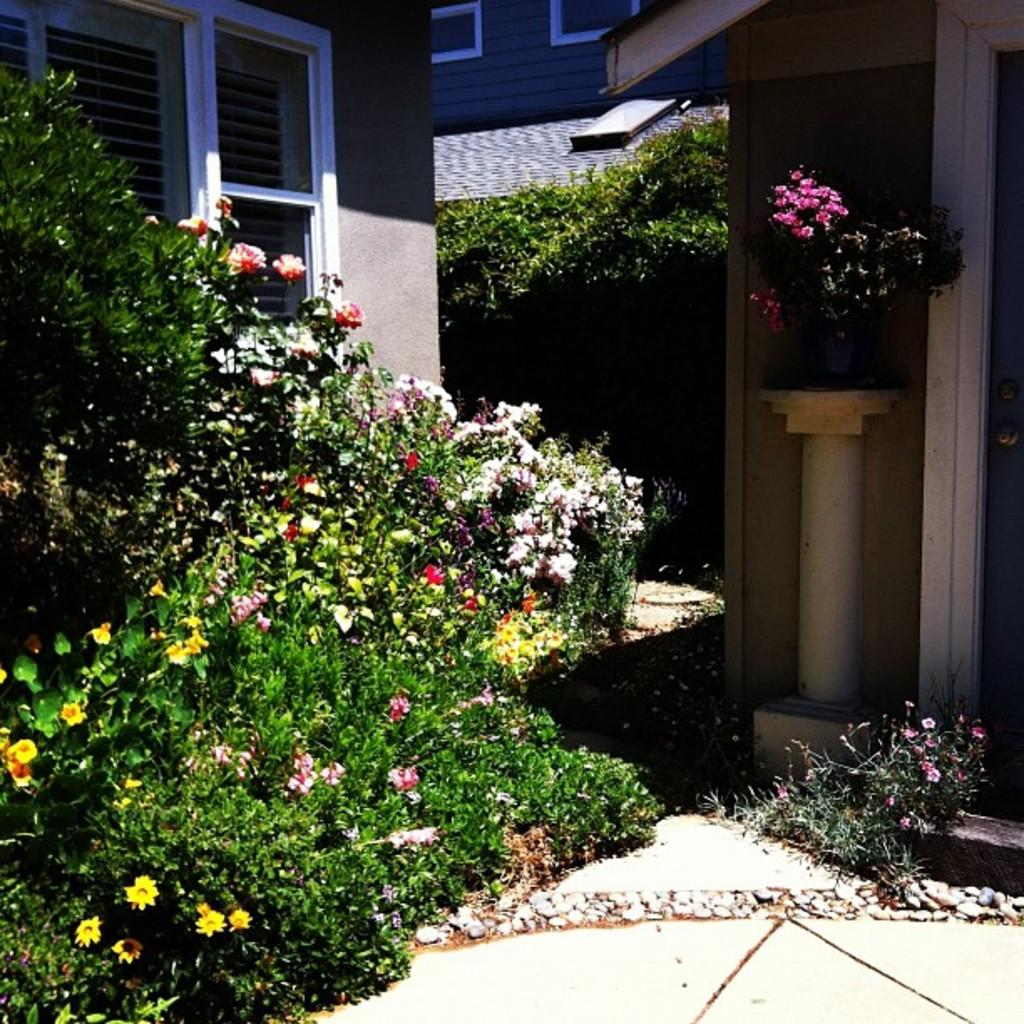What type of plants are visible in the image? There are plants with flowers in the image. What is the pot used for in the image? The pot is used to hold the plants with flowers. Where is the pot located in the image? The pot is on a platform in the image. What can be seen in the background of the image? There are buildings with windows in the background of the image. What type of music can be heard playing from the sponge in the image? There is no sponge or music present in the image. What type of truck is visible in the image? There is no truck present in the image. 